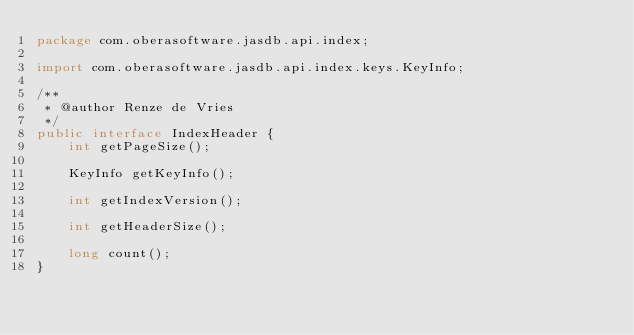<code> <loc_0><loc_0><loc_500><loc_500><_Java_>package com.oberasoftware.jasdb.api.index;

import com.oberasoftware.jasdb.api.index.keys.KeyInfo;

/**
 * @author Renze de Vries
 */
public interface IndexHeader {
    int getPageSize();

    KeyInfo getKeyInfo();

    int getIndexVersion();

    int getHeaderSize();

    long count();
}
</code> 